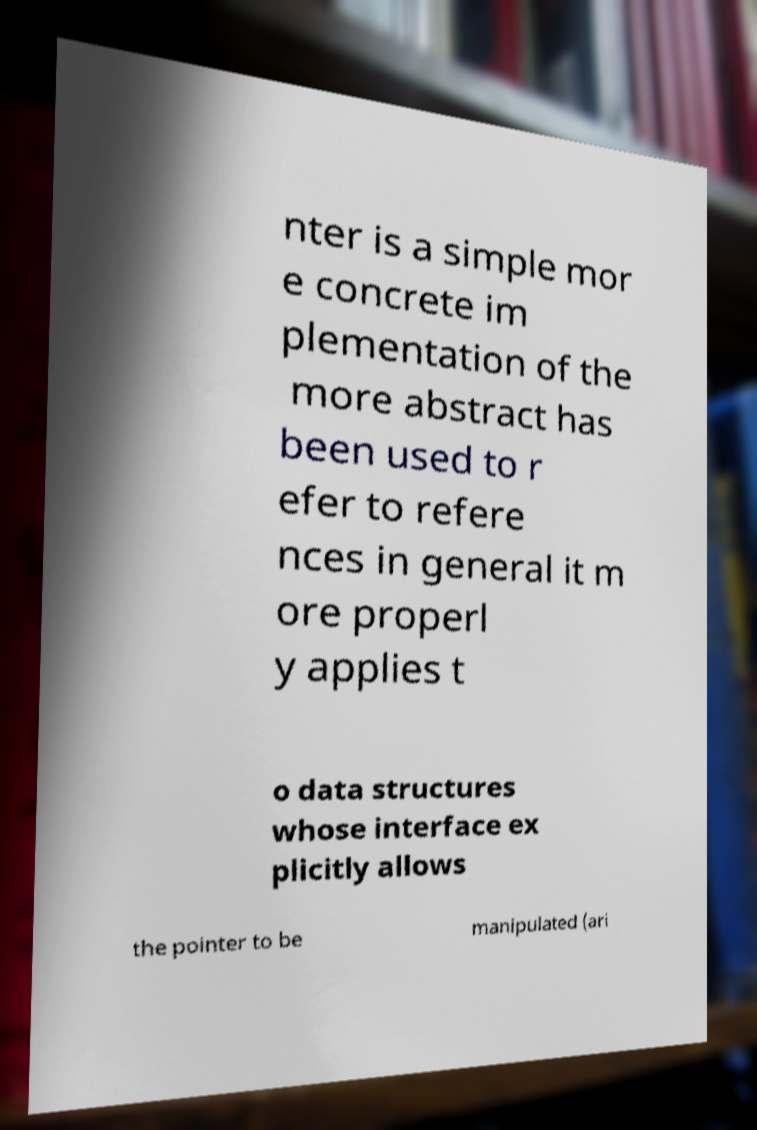Could you assist in decoding the text presented in this image and type it out clearly? nter is a simple mor e concrete im plementation of the more abstract has been used to r efer to refere nces in general it m ore properl y applies t o data structures whose interface ex plicitly allows the pointer to be manipulated (ari 